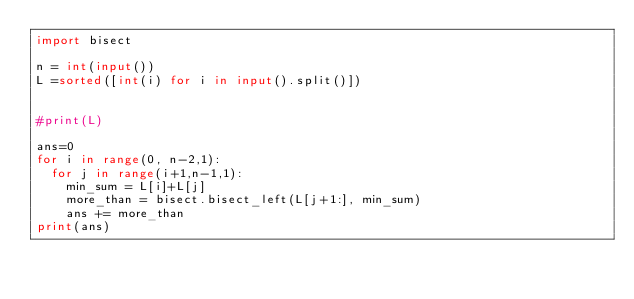<code> <loc_0><loc_0><loc_500><loc_500><_Python_>import bisect

n = int(input())
L =sorted([int(i) for i in input().split()])


#print(L)

ans=0
for i in range(0, n-2,1):
  for j in range(i+1,n-1,1):
    min_sum = L[i]+L[j]
    more_than = bisect.bisect_left(L[j+1:], min_sum)
    ans += more_than
print(ans)
</code> 